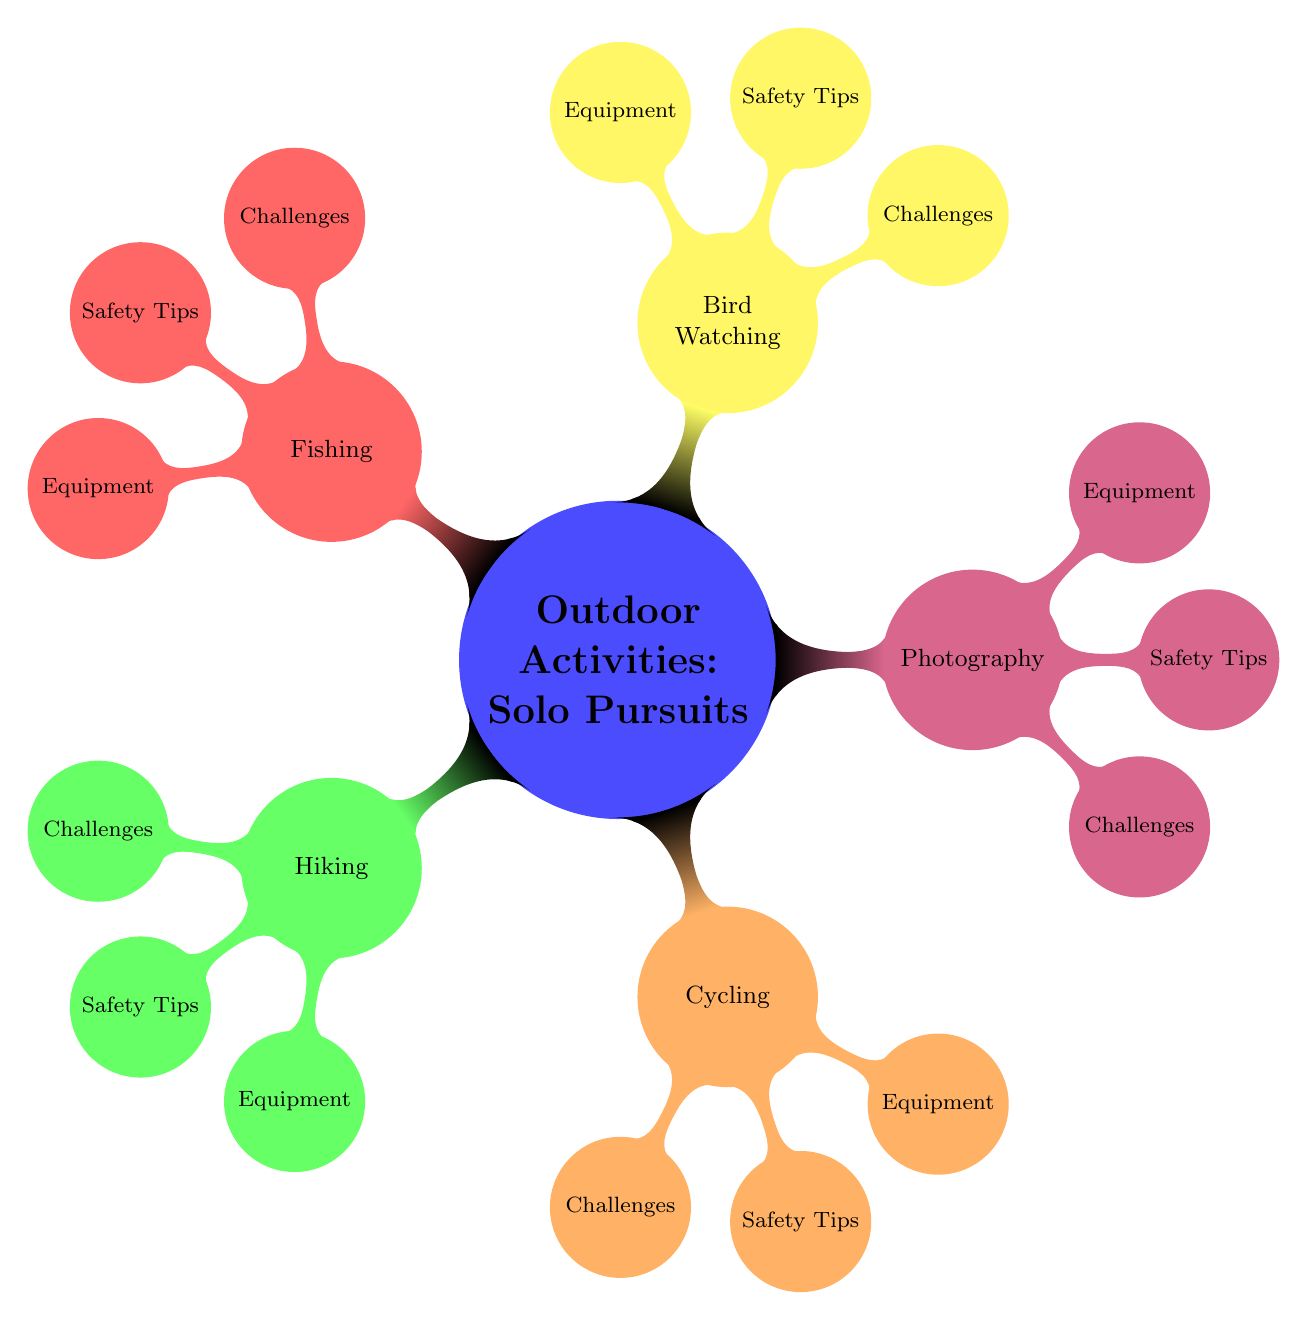What are the five outdoor activities listed under solo pursuits? The mind map directly shows five branches under the "Outdoor Activities: Solo Pursuits" node: Hiking, Cycling, Photography, Bird Watching, and Fishing.
Answer: Hiking, Cycling, Photography, Bird Watching, Fishing How many main activities are there in the diagram? The "Outdoor Activities: Solo Pursuits" node has five child nodes, each representing one of the main activities.
Answer: Five What challenges are associated with bird watching? By following the branch for Bird Watching, you can see that the node contains the text "Camouflage, Identifying species," which represents the challenges specific to this activity.
Answer: Camouflage, Identifying species What safety tip is shared for fishing? Under the Fishing node, the Safety Tips section states "Wear a life jacket, Use sunscreen," indicating the recommended precautions for this activity.
Answer: Wear a life jacket, Use sunscreen Which activity requires carrying a repair kit? Looking at the Cycling node, you can find the Equipment section, which lists "Repair kit" as a necessary item for this activity.
Answer: Repair kit What is one of the challenges of hiking? The node for Hiking includes a list of challenges, and one of them, as shown, is "Rocky terrain."
Answer: Rocky terrain Which activity has "Camera" listed as an essential piece of equipment? The Photography node includes "Camera" under its Equipment section, indicating that it is necessary for this activity.
Answer: Camera What is the main safety tip for cycling? The Cycling node explicitly states "Wear a helmet," emphasizing the main safety measure needed when cycling.
Answer: Wear a helmet How does fishing relate to safety compared to hiking? In the Fishing node, the safety tips include "Wear a life jacket, Use sunscreen," while in Hiking, it suggests "Inform someone, Carry a map and compass." Both focus on safety but involve different precautions based on the activity's environment.
Answer: Different precautions based on environment 